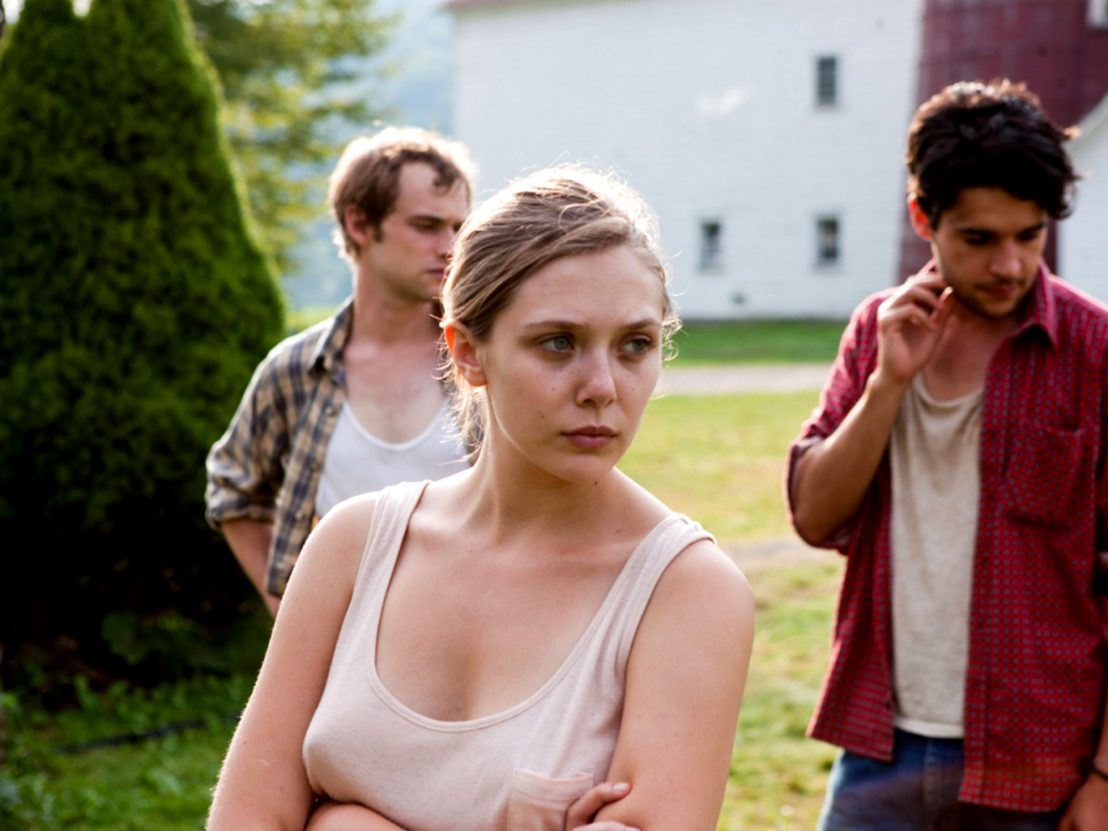How would you creatively interpret the symbolism of the red barn in the background? The red barn in the background can symbolize a multitude of things, often playing a significant role in storytelling. Its vivid red color contrasts with the muted tones of the characters' attire and their emotional state, perhaps symbolizing a beacon of hope or a reminder of passion and vitality in their lives. It could also represent a place of refuge, security, or a collective past that the characters share. The barn’s sturdy structure in comparison to the human fragility depicted in the scene adds a juxtaposition of permanence versus transient human emotions and struggles. Additionally, red often signifies danger or warning, implying that whatever they are dealing with could have serious consequences, thereby enhancing the tension of the moment. Can you write a short poem inspired by this scene? In fields where secrets whisper low,
A red barn stands, through ember’s glow,
Three hearts entwined in sorrow's dance,
With past's deep pain, a fleeting glance.
The trees, they hold their silent breath,
As shadows play on love and death,
In rustling leaves their stories meld,
Of lives once whole, now slowly felled.
With crossed arms, she bears the weight,
Of choices bound to twist their fate,
Two men beside, in troubled thought,
In nature's grasp, their solace sought. 